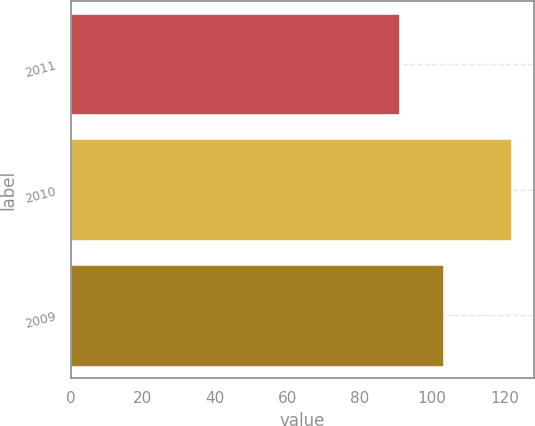Convert chart to OTSL. <chart><loc_0><loc_0><loc_500><loc_500><bar_chart><fcel>2011<fcel>2010<fcel>2009<nl><fcel>91<fcel>122<fcel>103<nl></chart> 